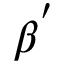Convert formula to latex. <formula><loc_0><loc_0><loc_500><loc_500>\beta ^ { ^ { \prime } }</formula> 